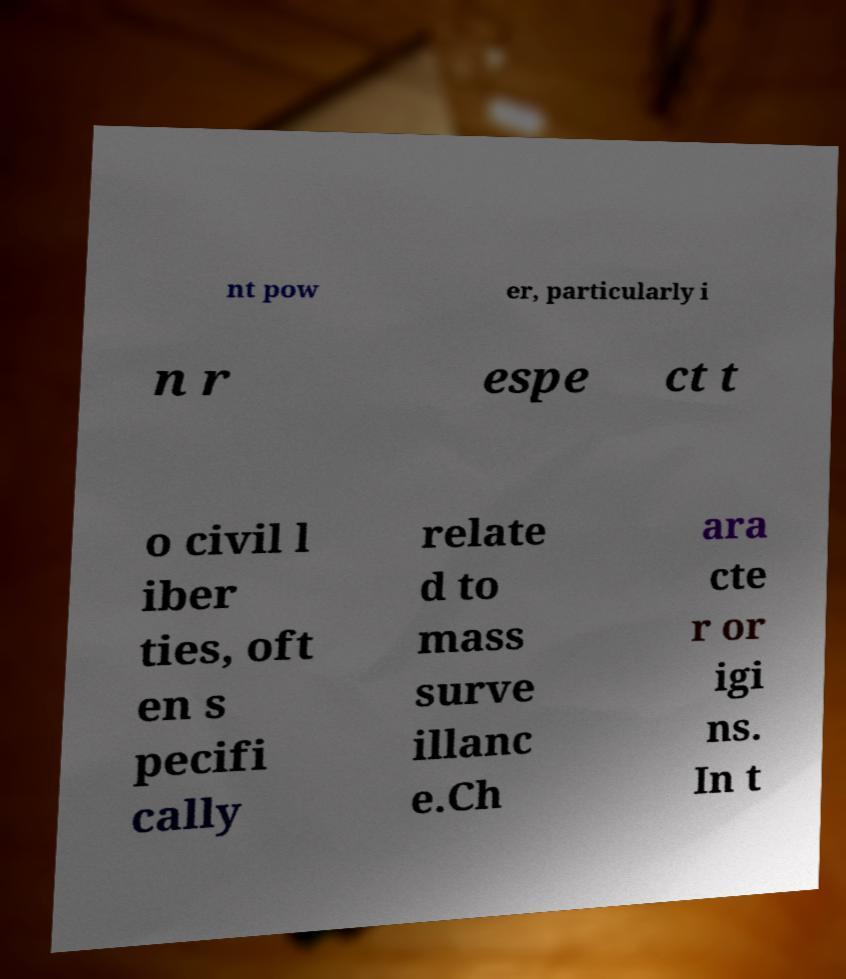For documentation purposes, I need the text within this image transcribed. Could you provide that? nt pow er, particularly i n r espe ct t o civil l iber ties, oft en s pecifi cally relate d to mass surve illanc e.Ch ara cte r or igi ns. In t 